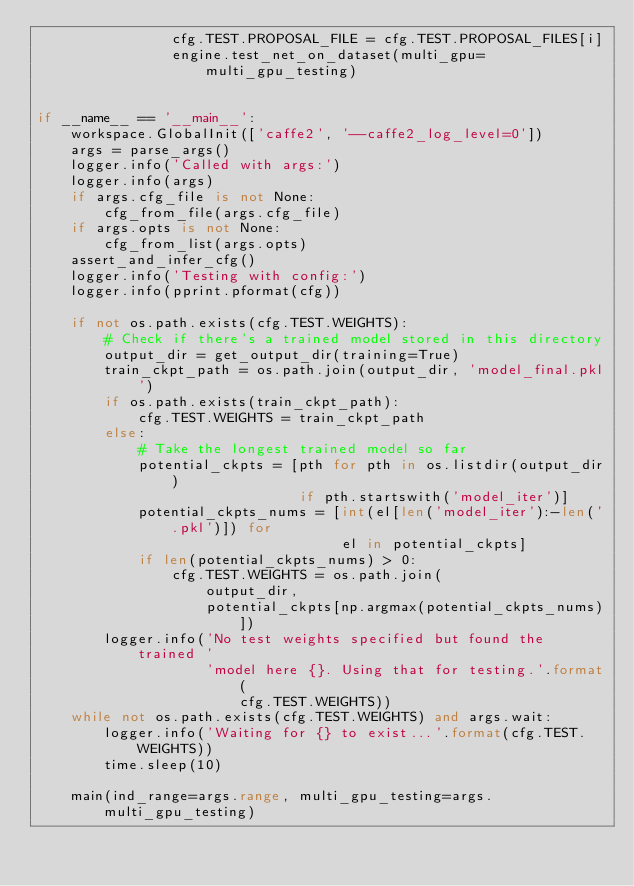<code> <loc_0><loc_0><loc_500><loc_500><_Python_>                cfg.TEST.PROPOSAL_FILE = cfg.TEST.PROPOSAL_FILES[i]
                engine.test_net_on_dataset(multi_gpu=multi_gpu_testing)


if __name__ == '__main__':
    workspace.GlobalInit(['caffe2', '--caffe2_log_level=0'])
    args = parse_args()
    logger.info('Called with args:')
    logger.info(args)
    if args.cfg_file is not None:
        cfg_from_file(args.cfg_file)
    if args.opts is not None:
        cfg_from_list(args.opts)
    assert_and_infer_cfg()
    logger.info('Testing with config:')
    logger.info(pprint.pformat(cfg))

    if not os.path.exists(cfg.TEST.WEIGHTS):
        # Check if there's a trained model stored in this directory
        output_dir = get_output_dir(training=True)
        train_ckpt_path = os.path.join(output_dir, 'model_final.pkl')
        if os.path.exists(train_ckpt_path):
            cfg.TEST.WEIGHTS = train_ckpt_path
        else:
            # Take the longest trained model so far
            potential_ckpts = [pth for pth in os.listdir(output_dir)
                               if pth.startswith('model_iter')]
            potential_ckpts_nums = [int(el[len('model_iter'):-len('.pkl')]) for
                                    el in potential_ckpts]
            if len(potential_ckpts_nums) > 0:
                cfg.TEST.WEIGHTS = os.path.join(
                    output_dir,
                    potential_ckpts[np.argmax(potential_ckpts_nums)])
        logger.info('No test weights specified but found the trained '
                    'model here {}. Using that for testing.'.format(
                        cfg.TEST.WEIGHTS))
    while not os.path.exists(cfg.TEST.WEIGHTS) and args.wait:
        logger.info('Waiting for {} to exist...'.format(cfg.TEST.WEIGHTS))
        time.sleep(10)

    main(ind_range=args.range, multi_gpu_testing=args.multi_gpu_testing)
</code> 